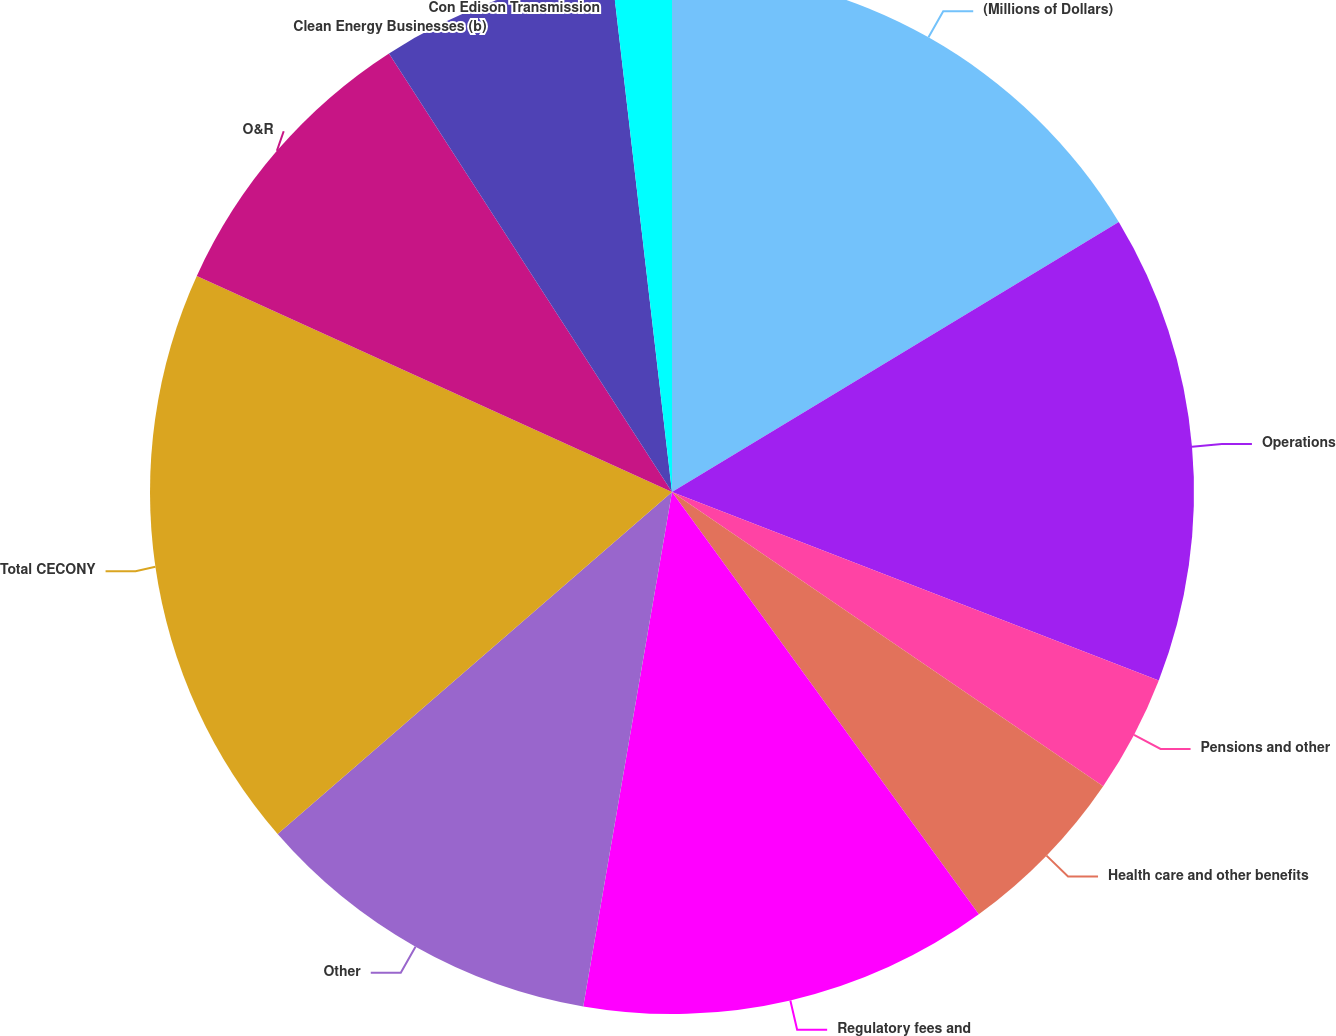Convert chart. <chart><loc_0><loc_0><loc_500><loc_500><pie_chart><fcel>(Millions of Dollars)<fcel>Operations<fcel>Pensions and other<fcel>Health care and other benefits<fcel>Regulatory fees and<fcel>Other<fcel>Total CECONY<fcel>O&R<fcel>Clean Energy Businesses (b)<fcel>Con Edison Transmission<nl><fcel>16.35%<fcel>14.53%<fcel>3.65%<fcel>5.47%<fcel>12.72%<fcel>10.91%<fcel>18.16%<fcel>9.09%<fcel>7.28%<fcel>1.84%<nl></chart> 